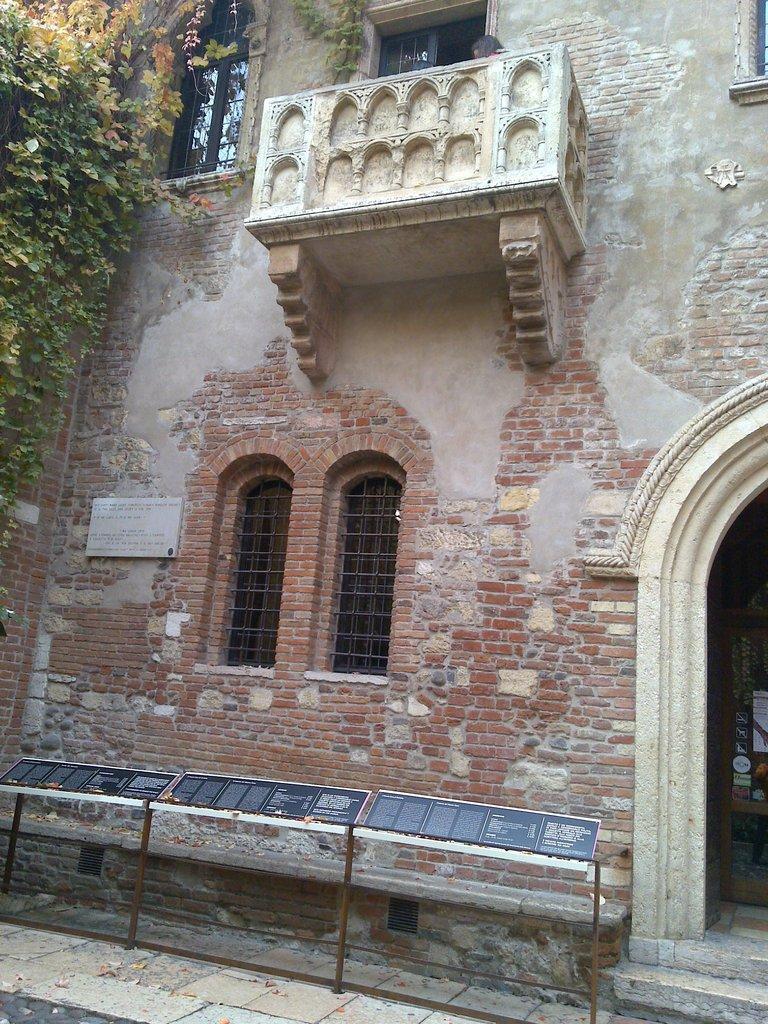In one or two sentences, can you explain what this image depicts? In this picture I can see a building, plants on the left side and few boards with some text. I can see windows and looks like a human at the top of the picture. 